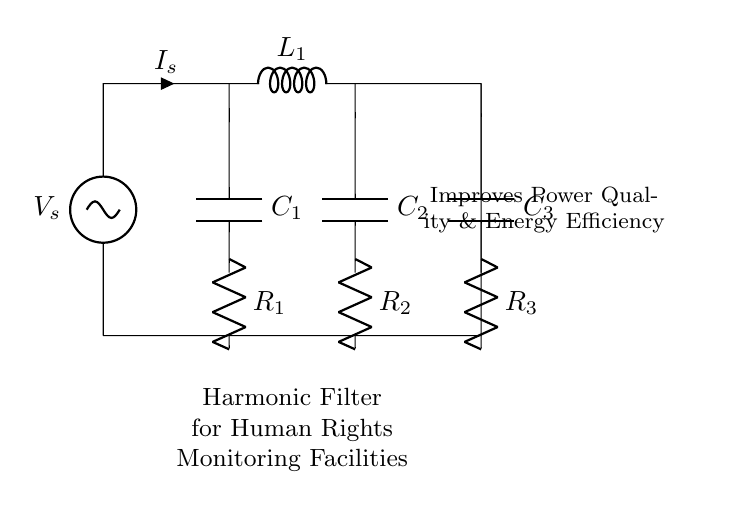What is the main purpose of this circuit? The circuit is designed to filter out harmonics, thus improving power quality and energy efficiency in monitoring facilities.
Answer: Harmonic Filter What components are used in this circuit? The circuit includes a voltage source, inductor, capacitors, and resistors. Each component plays a role in filtering harmonics.
Answer: Voltage source, inductor, capacitors, resistors What type of components are C1, C2, and C3? C1, C2, and C3 are capacitors, which are used to store energy and help in filtering harmonic frequencies in the circuit.
Answer: Capacitors How many resistors are there in the circuit? There are three resistors in the circuit (R1, R2, and R3), which are placed in series with the capacitors.
Answer: Three What is the relationship between the voltage source and the components? The voltage source provides electrical energy to the circuit, which flows through the inductor, capacitors, and resistors, filtering the harmonics before reaching the load.
Answer: Energy source What is the main benefit of adding a harmonic filter in power systems? A harmonic filter reduces harmonic distortion, leading to improved efficiency and reliability of power systems, especially in sensitive environments like human rights monitoring facilities.
Answer: Improved efficiency 